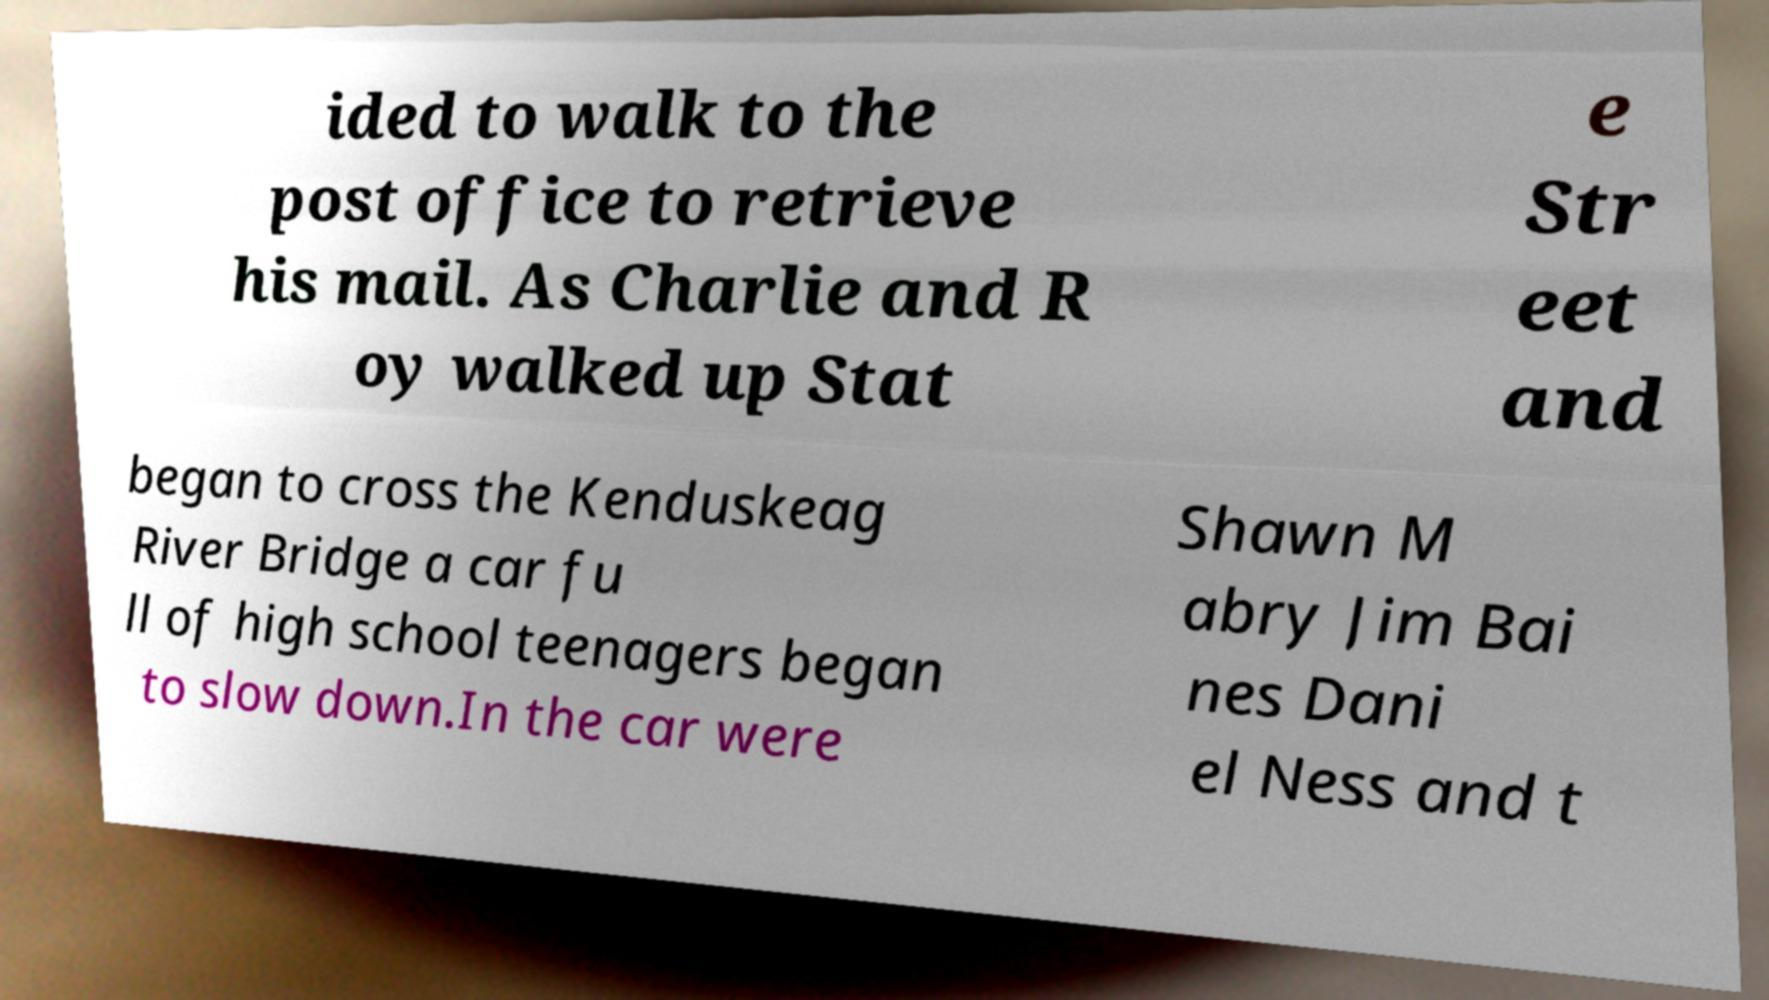There's text embedded in this image that I need extracted. Can you transcribe it verbatim? ided to walk to the post office to retrieve his mail. As Charlie and R oy walked up Stat e Str eet and began to cross the Kenduskeag River Bridge a car fu ll of high school teenagers began to slow down.In the car were Shawn M abry Jim Bai nes Dani el Ness and t 